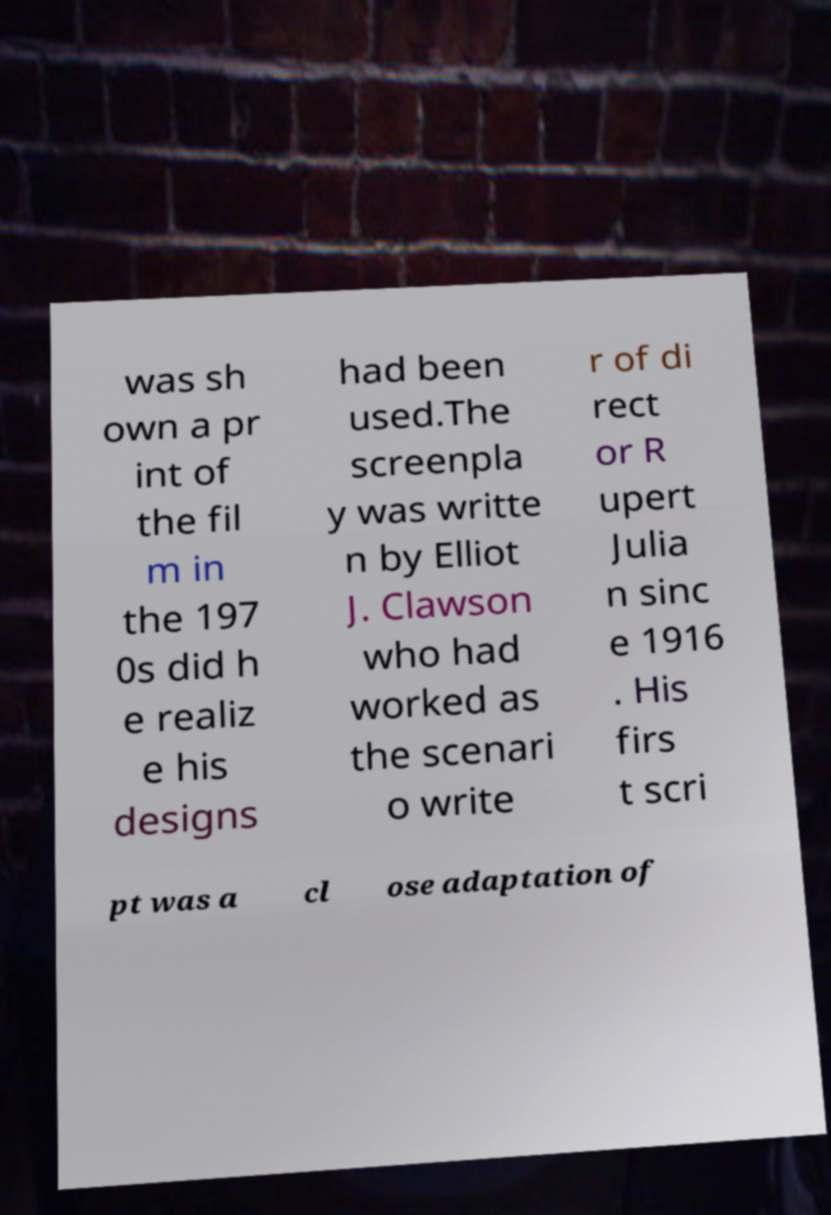For documentation purposes, I need the text within this image transcribed. Could you provide that? was sh own a pr int of the fil m in the 197 0s did h e realiz e his designs had been used.The screenpla y was writte n by Elliot J. Clawson who had worked as the scenari o write r of di rect or R upert Julia n sinc e 1916 . His firs t scri pt was a cl ose adaptation of 